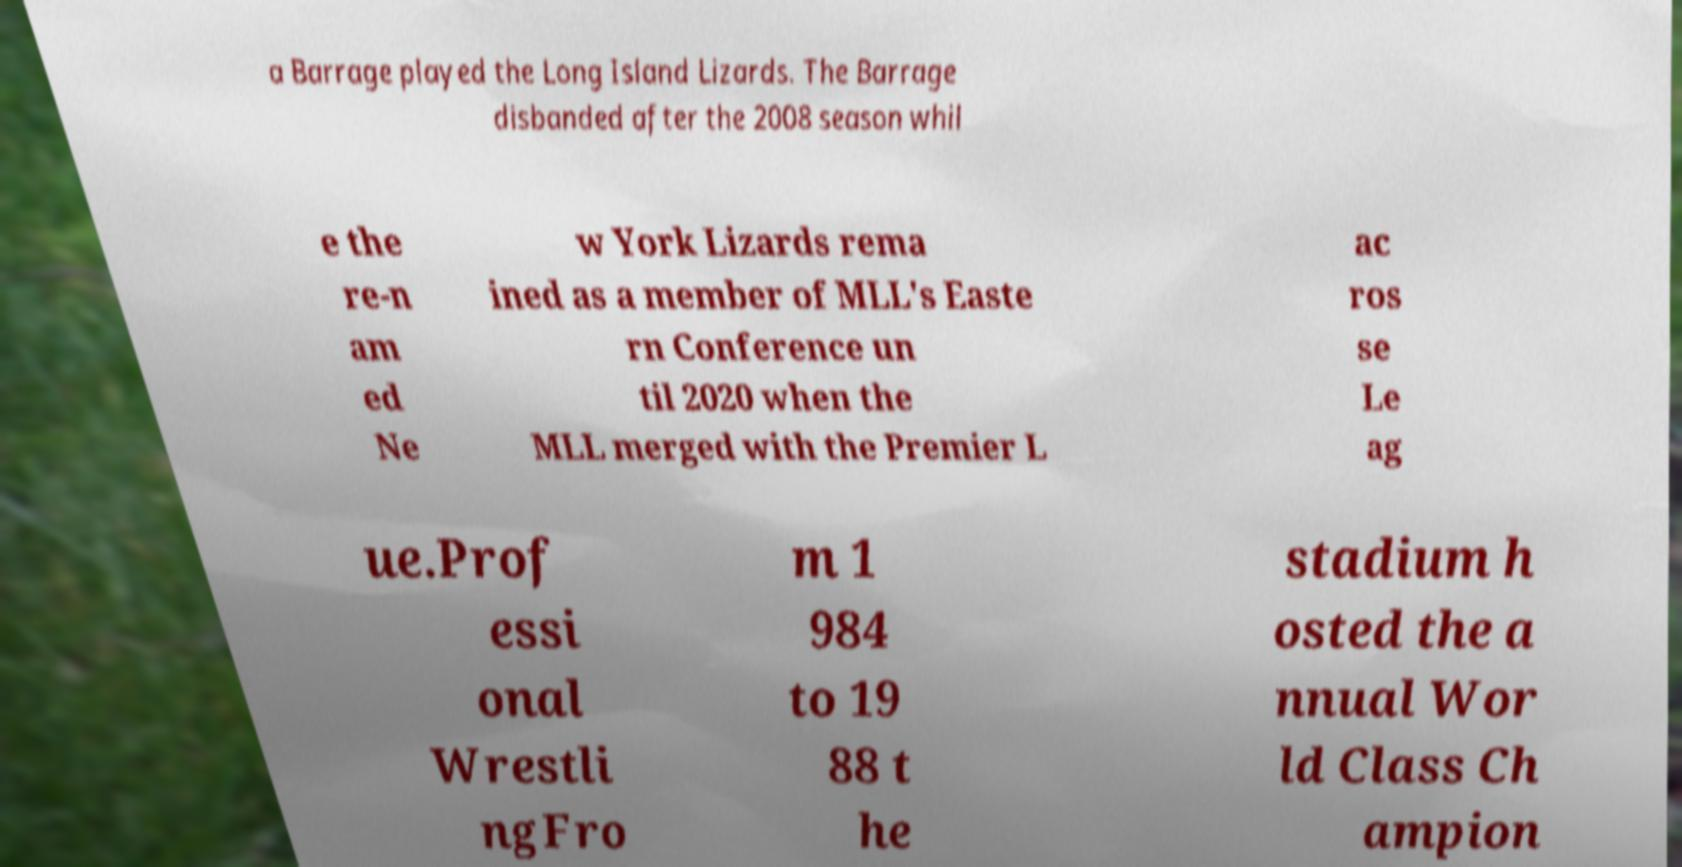Could you assist in decoding the text presented in this image and type it out clearly? a Barrage played the Long Island Lizards. The Barrage disbanded after the 2008 season whil e the re-n am ed Ne w York Lizards rema ined as a member of MLL's Easte rn Conference un til 2020 when the MLL merged with the Premier L ac ros se Le ag ue.Prof essi onal Wrestli ngFro m 1 984 to 19 88 t he stadium h osted the a nnual Wor ld Class Ch ampion 